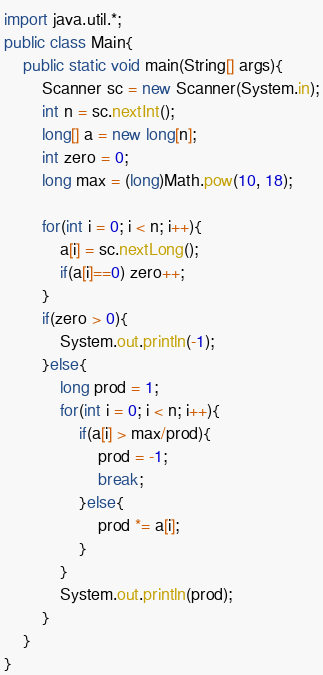Convert code to text. <code><loc_0><loc_0><loc_500><loc_500><_Java_>import java.util.*;
public class Main{
	public static void main(String[] args){
    	Scanner sc = new Scanner(System.in);
      	int n = sc.nextInt();
      	long[] a = new long[n];
      	int zero = 0;
      	long max = (long)Math.pow(10, 18);
      
      	for(int i = 0; i < n; i++){
        	a[i] = sc.nextLong();
          	if(a[i]==0) zero++;
        }
      	if(zero > 0){
        	System.out.println(-1);
        }else{
          	long prod = 1;
        	for(int i = 0; i < n; i++){
            	if(a[i] > max/prod){
                	prod = -1;
                    break;
                }else{
                	prod *= a[i];
                }
            }
          	System.out.println(prod);
        }
    }
}
</code> 